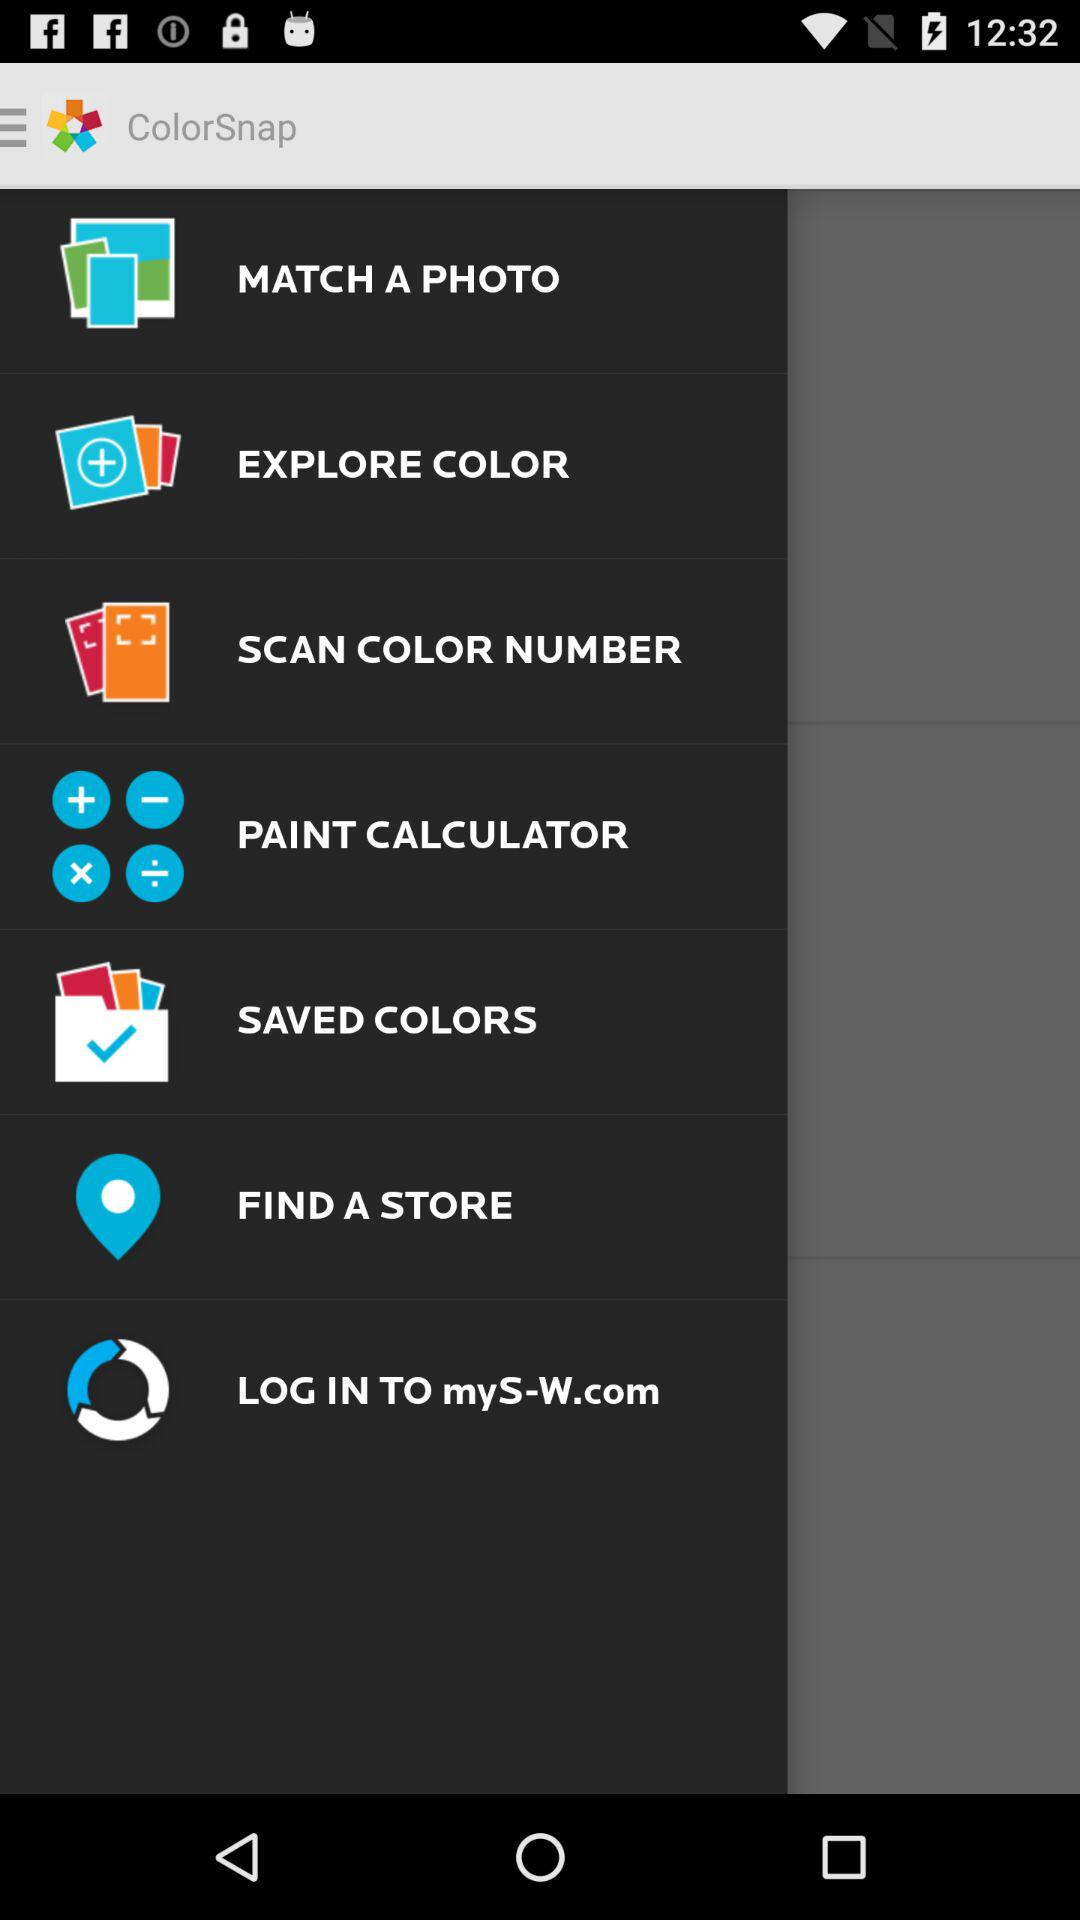What is the application name? The application name is "ColorSnap". 